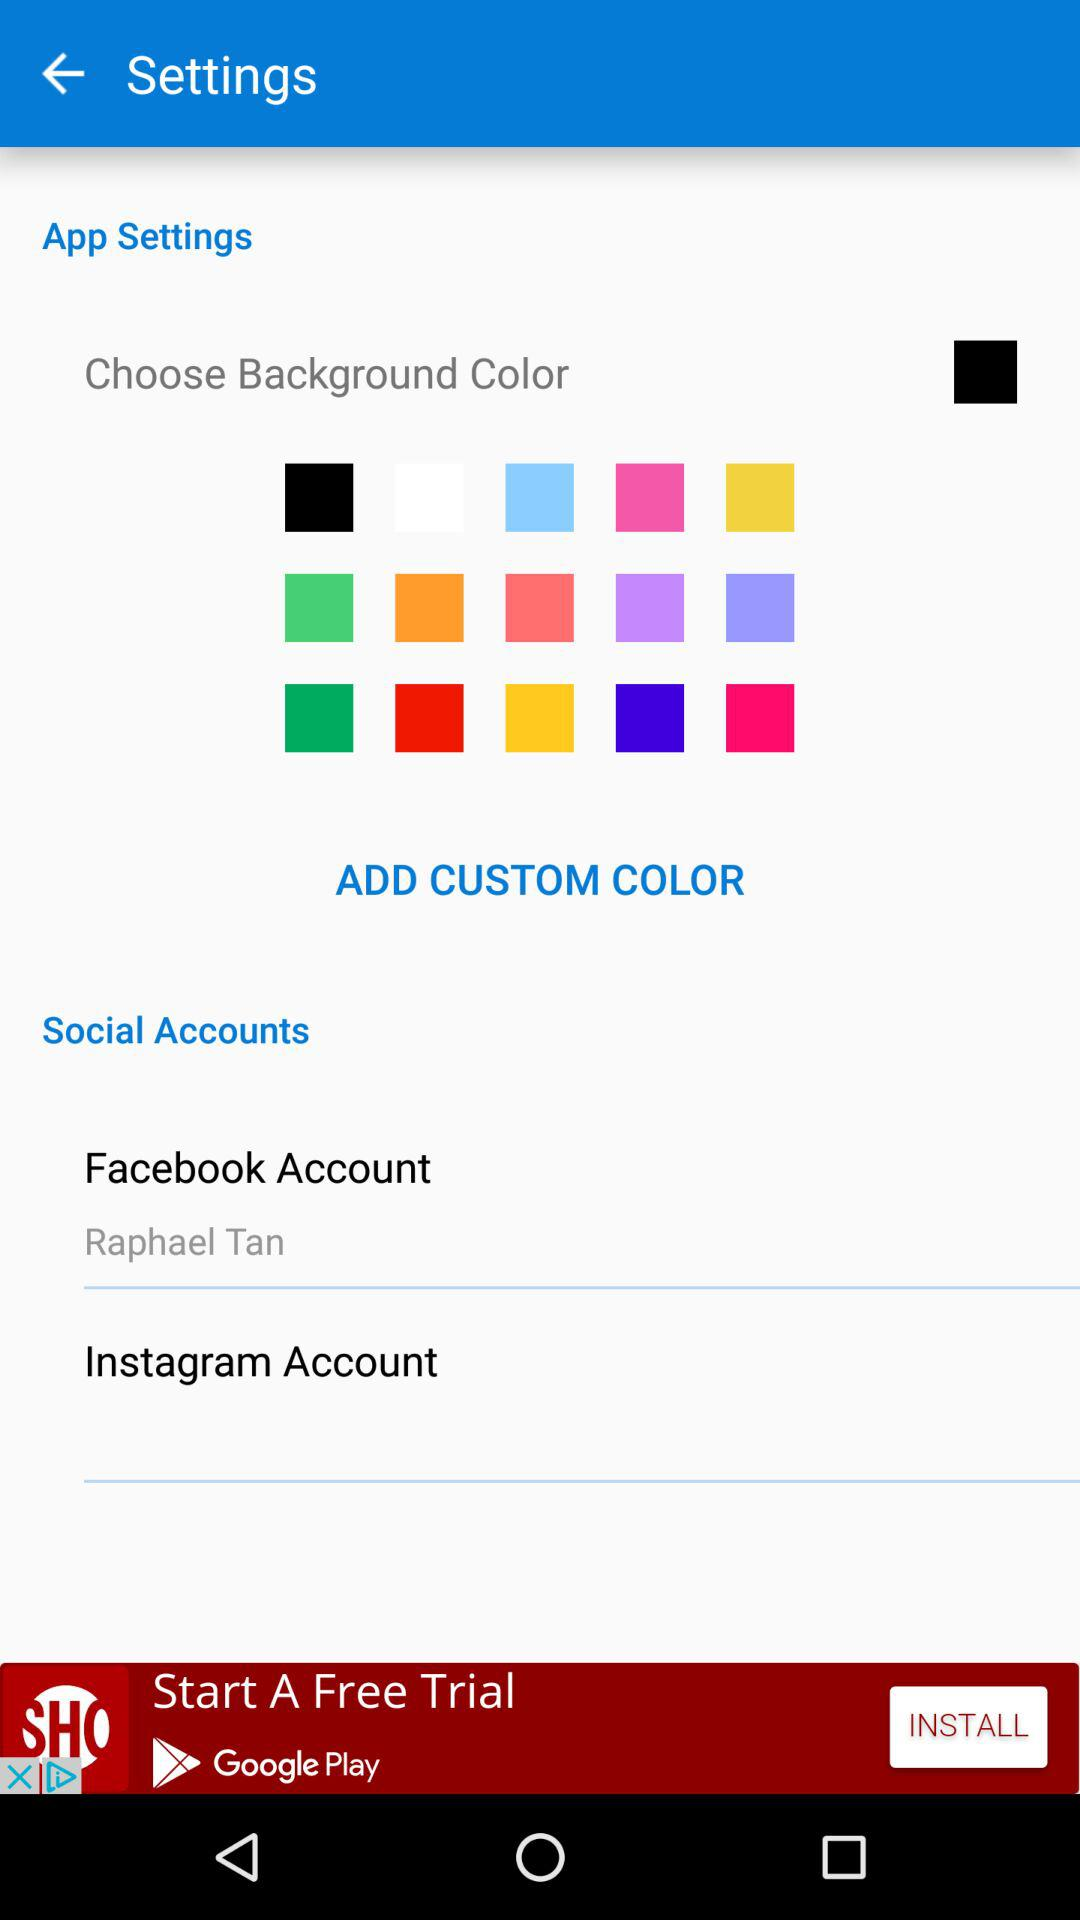How to Add Custom Color?
When the provided information is insufficient, respond with <no answer>. <no answer> 